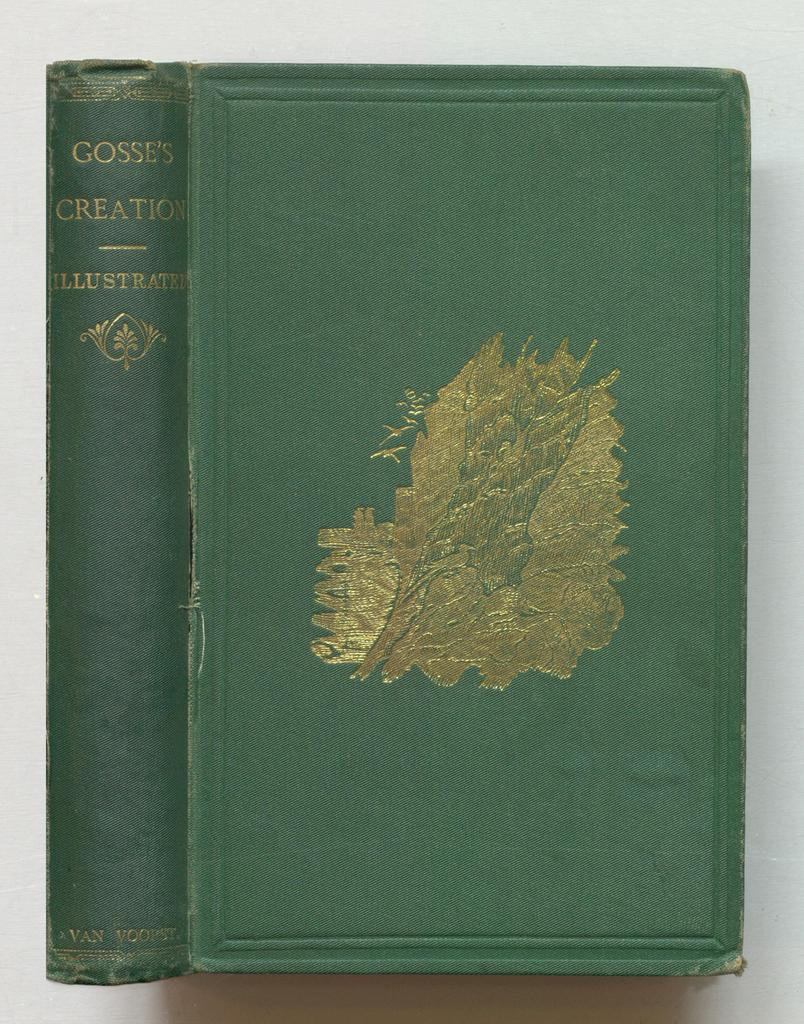<image>
Share a concise interpretation of the image provided. the word Gosse's that is on the side of a book 